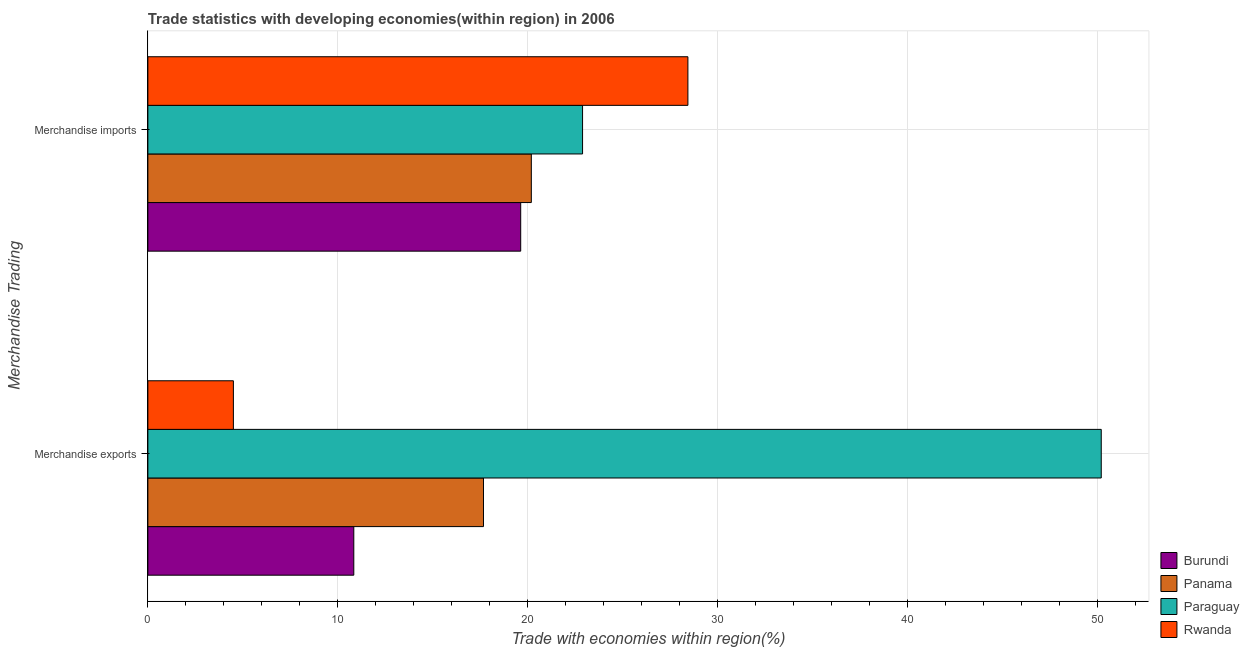How many different coloured bars are there?
Ensure brevity in your answer.  4. How many groups of bars are there?
Your response must be concise. 2. How many bars are there on the 2nd tick from the bottom?
Your answer should be compact. 4. What is the label of the 1st group of bars from the top?
Offer a very short reply. Merchandise imports. What is the merchandise exports in Panama?
Provide a succinct answer. 17.67. Across all countries, what is the maximum merchandise imports?
Provide a succinct answer. 28.44. Across all countries, what is the minimum merchandise exports?
Your answer should be compact. 4.5. In which country was the merchandise imports maximum?
Give a very brief answer. Rwanda. In which country was the merchandise exports minimum?
Make the answer very short. Rwanda. What is the total merchandise exports in the graph?
Keep it short and to the point. 83.23. What is the difference between the merchandise imports in Burundi and that in Paraguay?
Give a very brief answer. -3.26. What is the difference between the merchandise exports in Burundi and the merchandise imports in Panama?
Make the answer very short. -9.35. What is the average merchandise imports per country?
Provide a succinct answer. 22.79. What is the difference between the merchandise imports and merchandise exports in Burundi?
Your response must be concise. 8.79. What is the ratio of the merchandise imports in Burundi to that in Rwanda?
Offer a very short reply. 0.69. What does the 3rd bar from the top in Merchandise exports represents?
Offer a very short reply. Panama. What does the 4th bar from the bottom in Merchandise exports represents?
Your response must be concise. Rwanda. What is the difference between two consecutive major ticks on the X-axis?
Offer a terse response. 10. Are the values on the major ticks of X-axis written in scientific E-notation?
Your answer should be very brief. No. Where does the legend appear in the graph?
Your answer should be compact. Bottom right. How are the legend labels stacked?
Give a very brief answer. Vertical. What is the title of the graph?
Provide a succinct answer. Trade statistics with developing economies(within region) in 2006. Does "Rwanda" appear as one of the legend labels in the graph?
Keep it short and to the point. Yes. What is the label or title of the X-axis?
Your answer should be compact. Trade with economies within region(%). What is the label or title of the Y-axis?
Make the answer very short. Merchandise Trading. What is the Trade with economies within region(%) in Burundi in Merchandise exports?
Give a very brief answer. 10.84. What is the Trade with economies within region(%) of Panama in Merchandise exports?
Offer a very short reply. 17.67. What is the Trade with economies within region(%) in Paraguay in Merchandise exports?
Your response must be concise. 50.21. What is the Trade with economies within region(%) of Rwanda in Merchandise exports?
Make the answer very short. 4.5. What is the Trade with economies within region(%) of Burundi in Merchandise imports?
Give a very brief answer. 19.63. What is the Trade with economies within region(%) in Panama in Merchandise imports?
Keep it short and to the point. 20.19. What is the Trade with economies within region(%) in Paraguay in Merchandise imports?
Offer a very short reply. 22.89. What is the Trade with economies within region(%) of Rwanda in Merchandise imports?
Offer a terse response. 28.44. Across all Merchandise Trading, what is the maximum Trade with economies within region(%) in Burundi?
Your answer should be compact. 19.63. Across all Merchandise Trading, what is the maximum Trade with economies within region(%) of Panama?
Offer a terse response. 20.19. Across all Merchandise Trading, what is the maximum Trade with economies within region(%) of Paraguay?
Your response must be concise. 50.21. Across all Merchandise Trading, what is the maximum Trade with economies within region(%) of Rwanda?
Provide a succinct answer. 28.44. Across all Merchandise Trading, what is the minimum Trade with economies within region(%) of Burundi?
Make the answer very short. 10.84. Across all Merchandise Trading, what is the minimum Trade with economies within region(%) of Panama?
Give a very brief answer. 17.67. Across all Merchandise Trading, what is the minimum Trade with economies within region(%) in Paraguay?
Provide a short and direct response. 22.89. Across all Merchandise Trading, what is the minimum Trade with economies within region(%) of Rwanda?
Give a very brief answer. 4.5. What is the total Trade with economies within region(%) of Burundi in the graph?
Ensure brevity in your answer.  30.48. What is the total Trade with economies within region(%) in Panama in the graph?
Offer a terse response. 37.87. What is the total Trade with economies within region(%) of Paraguay in the graph?
Give a very brief answer. 73.1. What is the total Trade with economies within region(%) in Rwanda in the graph?
Your response must be concise. 32.94. What is the difference between the Trade with economies within region(%) in Burundi in Merchandise exports and that in Merchandise imports?
Your answer should be very brief. -8.79. What is the difference between the Trade with economies within region(%) of Panama in Merchandise exports and that in Merchandise imports?
Keep it short and to the point. -2.52. What is the difference between the Trade with economies within region(%) of Paraguay in Merchandise exports and that in Merchandise imports?
Give a very brief answer. 27.31. What is the difference between the Trade with economies within region(%) in Rwanda in Merchandise exports and that in Merchandise imports?
Ensure brevity in your answer.  -23.93. What is the difference between the Trade with economies within region(%) in Burundi in Merchandise exports and the Trade with economies within region(%) in Panama in Merchandise imports?
Your response must be concise. -9.35. What is the difference between the Trade with economies within region(%) in Burundi in Merchandise exports and the Trade with economies within region(%) in Paraguay in Merchandise imports?
Offer a very short reply. -12.05. What is the difference between the Trade with economies within region(%) in Burundi in Merchandise exports and the Trade with economies within region(%) in Rwanda in Merchandise imports?
Your answer should be very brief. -17.59. What is the difference between the Trade with economies within region(%) in Panama in Merchandise exports and the Trade with economies within region(%) in Paraguay in Merchandise imports?
Offer a very short reply. -5.22. What is the difference between the Trade with economies within region(%) in Panama in Merchandise exports and the Trade with economies within region(%) in Rwanda in Merchandise imports?
Give a very brief answer. -10.77. What is the difference between the Trade with economies within region(%) of Paraguay in Merchandise exports and the Trade with economies within region(%) of Rwanda in Merchandise imports?
Provide a succinct answer. 21.77. What is the average Trade with economies within region(%) of Burundi per Merchandise Trading?
Offer a very short reply. 15.24. What is the average Trade with economies within region(%) of Panama per Merchandise Trading?
Provide a short and direct response. 18.93. What is the average Trade with economies within region(%) of Paraguay per Merchandise Trading?
Offer a terse response. 36.55. What is the average Trade with economies within region(%) of Rwanda per Merchandise Trading?
Provide a succinct answer. 16.47. What is the difference between the Trade with economies within region(%) in Burundi and Trade with economies within region(%) in Panama in Merchandise exports?
Your answer should be compact. -6.83. What is the difference between the Trade with economies within region(%) in Burundi and Trade with economies within region(%) in Paraguay in Merchandise exports?
Offer a very short reply. -39.36. What is the difference between the Trade with economies within region(%) of Burundi and Trade with economies within region(%) of Rwanda in Merchandise exports?
Your response must be concise. 6.34. What is the difference between the Trade with economies within region(%) in Panama and Trade with economies within region(%) in Paraguay in Merchandise exports?
Your answer should be compact. -32.53. What is the difference between the Trade with economies within region(%) in Panama and Trade with economies within region(%) in Rwanda in Merchandise exports?
Keep it short and to the point. 13.17. What is the difference between the Trade with economies within region(%) of Paraguay and Trade with economies within region(%) of Rwanda in Merchandise exports?
Make the answer very short. 45.7. What is the difference between the Trade with economies within region(%) in Burundi and Trade with economies within region(%) in Panama in Merchandise imports?
Keep it short and to the point. -0.56. What is the difference between the Trade with economies within region(%) in Burundi and Trade with economies within region(%) in Paraguay in Merchandise imports?
Offer a terse response. -3.26. What is the difference between the Trade with economies within region(%) of Burundi and Trade with economies within region(%) of Rwanda in Merchandise imports?
Ensure brevity in your answer.  -8.8. What is the difference between the Trade with economies within region(%) in Panama and Trade with economies within region(%) in Paraguay in Merchandise imports?
Provide a succinct answer. -2.7. What is the difference between the Trade with economies within region(%) of Panama and Trade with economies within region(%) of Rwanda in Merchandise imports?
Provide a succinct answer. -8.25. What is the difference between the Trade with economies within region(%) of Paraguay and Trade with economies within region(%) of Rwanda in Merchandise imports?
Your response must be concise. -5.55. What is the ratio of the Trade with economies within region(%) in Burundi in Merchandise exports to that in Merchandise imports?
Ensure brevity in your answer.  0.55. What is the ratio of the Trade with economies within region(%) in Panama in Merchandise exports to that in Merchandise imports?
Your answer should be compact. 0.88. What is the ratio of the Trade with economies within region(%) of Paraguay in Merchandise exports to that in Merchandise imports?
Provide a short and direct response. 2.19. What is the ratio of the Trade with economies within region(%) of Rwanda in Merchandise exports to that in Merchandise imports?
Your answer should be compact. 0.16. What is the difference between the highest and the second highest Trade with economies within region(%) in Burundi?
Provide a short and direct response. 8.79. What is the difference between the highest and the second highest Trade with economies within region(%) of Panama?
Provide a short and direct response. 2.52. What is the difference between the highest and the second highest Trade with economies within region(%) in Paraguay?
Your answer should be very brief. 27.31. What is the difference between the highest and the second highest Trade with economies within region(%) in Rwanda?
Make the answer very short. 23.93. What is the difference between the highest and the lowest Trade with economies within region(%) in Burundi?
Your answer should be very brief. 8.79. What is the difference between the highest and the lowest Trade with economies within region(%) in Panama?
Your response must be concise. 2.52. What is the difference between the highest and the lowest Trade with economies within region(%) of Paraguay?
Your answer should be very brief. 27.31. What is the difference between the highest and the lowest Trade with economies within region(%) of Rwanda?
Ensure brevity in your answer.  23.93. 